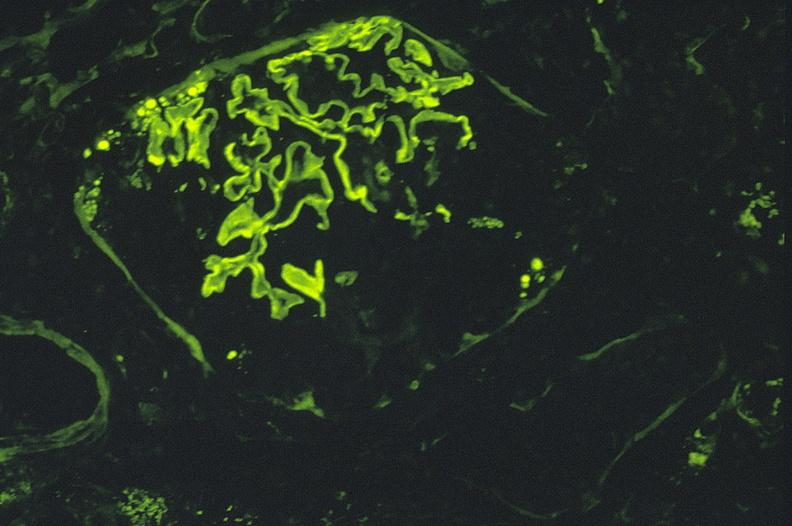s urinary present?
Answer the question using a single word or phrase. Yes 